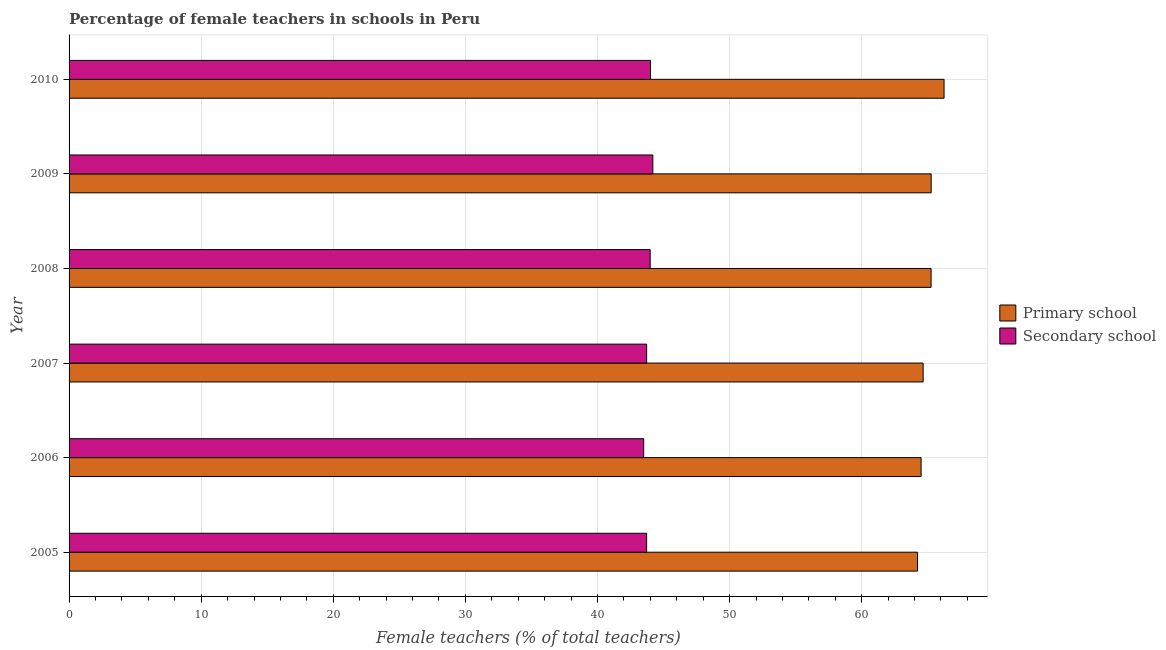How many different coloured bars are there?
Offer a terse response. 2. How many groups of bars are there?
Your response must be concise. 6. Are the number of bars on each tick of the Y-axis equal?
Ensure brevity in your answer.  Yes. What is the percentage of female teachers in secondary schools in 2010?
Give a very brief answer. 44.01. Across all years, what is the maximum percentage of female teachers in primary schools?
Provide a short and direct response. 66.23. Across all years, what is the minimum percentage of female teachers in secondary schools?
Make the answer very short. 43.5. What is the total percentage of female teachers in primary schools in the graph?
Provide a succinct answer. 390.12. What is the difference between the percentage of female teachers in secondary schools in 2007 and that in 2010?
Your answer should be compact. -0.29. What is the difference between the percentage of female teachers in secondary schools in 2005 and the percentage of female teachers in primary schools in 2007?
Provide a succinct answer. -20.93. What is the average percentage of female teachers in primary schools per year?
Provide a succinct answer. 65.02. In the year 2008, what is the difference between the percentage of female teachers in secondary schools and percentage of female teachers in primary schools?
Keep it short and to the point. -21.26. In how many years, is the percentage of female teachers in primary schools greater than 44 %?
Offer a very short reply. 6. What is the difference between the highest and the second highest percentage of female teachers in primary schools?
Provide a succinct answer. 0.97. What is the difference between the highest and the lowest percentage of female teachers in secondary schools?
Provide a succinct answer. 0.69. In how many years, is the percentage of female teachers in secondary schools greater than the average percentage of female teachers in secondary schools taken over all years?
Make the answer very short. 3. Is the sum of the percentage of female teachers in secondary schools in 2007 and 2010 greater than the maximum percentage of female teachers in primary schools across all years?
Your response must be concise. Yes. What does the 2nd bar from the top in 2008 represents?
Offer a terse response. Primary school. What does the 1st bar from the bottom in 2008 represents?
Give a very brief answer. Primary school. How many bars are there?
Make the answer very short. 12. Are the values on the major ticks of X-axis written in scientific E-notation?
Keep it short and to the point. No. Does the graph contain grids?
Give a very brief answer. Yes. Where does the legend appear in the graph?
Ensure brevity in your answer.  Center right. How many legend labels are there?
Your response must be concise. 2. What is the title of the graph?
Offer a terse response. Percentage of female teachers in schools in Peru. What is the label or title of the X-axis?
Ensure brevity in your answer.  Female teachers (% of total teachers). What is the Female teachers (% of total teachers) of Primary school in 2005?
Give a very brief answer. 64.23. What is the Female teachers (% of total teachers) of Secondary school in 2005?
Keep it short and to the point. 43.72. What is the Female teachers (% of total teachers) in Primary school in 2006?
Provide a succinct answer. 64.5. What is the Female teachers (% of total teachers) in Secondary school in 2006?
Your answer should be very brief. 43.5. What is the Female teachers (% of total teachers) in Primary school in 2007?
Give a very brief answer. 64.65. What is the Female teachers (% of total teachers) in Secondary school in 2007?
Offer a very short reply. 43.72. What is the Female teachers (% of total teachers) of Primary school in 2008?
Keep it short and to the point. 65.25. What is the Female teachers (% of total teachers) of Secondary school in 2008?
Make the answer very short. 43.99. What is the Female teachers (% of total teachers) of Primary school in 2009?
Give a very brief answer. 65.26. What is the Female teachers (% of total teachers) of Secondary school in 2009?
Keep it short and to the point. 44.19. What is the Female teachers (% of total teachers) in Primary school in 2010?
Offer a very short reply. 66.23. What is the Female teachers (% of total teachers) of Secondary school in 2010?
Offer a terse response. 44.01. Across all years, what is the maximum Female teachers (% of total teachers) of Primary school?
Ensure brevity in your answer.  66.23. Across all years, what is the maximum Female teachers (% of total teachers) of Secondary school?
Make the answer very short. 44.19. Across all years, what is the minimum Female teachers (% of total teachers) in Primary school?
Offer a terse response. 64.23. Across all years, what is the minimum Female teachers (% of total teachers) of Secondary school?
Provide a succinct answer. 43.5. What is the total Female teachers (% of total teachers) of Primary school in the graph?
Offer a very short reply. 390.12. What is the total Female teachers (% of total teachers) in Secondary school in the graph?
Provide a short and direct response. 263.13. What is the difference between the Female teachers (% of total teachers) in Primary school in 2005 and that in 2006?
Make the answer very short. -0.27. What is the difference between the Female teachers (% of total teachers) in Secondary school in 2005 and that in 2006?
Your answer should be very brief. 0.22. What is the difference between the Female teachers (% of total teachers) of Primary school in 2005 and that in 2007?
Your response must be concise. -0.42. What is the difference between the Female teachers (% of total teachers) of Secondary school in 2005 and that in 2007?
Make the answer very short. -0. What is the difference between the Female teachers (% of total teachers) in Primary school in 2005 and that in 2008?
Make the answer very short. -1.03. What is the difference between the Female teachers (% of total teachers) in Secondary school in 2005 and that in 2008?
Ensure brevity in your answer.  -0.27. What is the difference between the Female teachers (% of total teachers) of Primary school in 2005 and that in 2009?
Make the answer very short. -1.03. What is the difference between the Female teachers (% of total teachers) in Secondary school in 2005 and that in 2009?
Give a very brief answer. -0.47. What is the difference between the Female teachers (% of total teachers) in Primary school in 2005 and that in 2010?
Provide a short and direct response. -2.01. What is the difference between the Female teachers (% of total teachers) of Secondary school in 2005 and that in 2010?
Give a very brief answer. -0.29. What is the difference between the Female teachers (% of total teachers) of Primary school in 2006 and that in 2007?
Give a very brief answer. -0.15. What is the difference between the Female teachers (% of total teachers) in Secondary school in 2006 and that in 2007?
Give a very brief answer. -0.22. What is the difference between the Female teachers (% of total teachers) in Primary school in 2006 and that in 2008?
Offer a terse response. -0.76. What is the difference between the Female teachers (% of total teachers) of Secondary school in 2006 and that in 2008?
Make the answer very short. -0.49. What is the difference between the Female teachers (% of total teachers) in Primary school in 2006 and that in 2009?
Give a very brief answer. -0.76. What is the difference between the Female teachers (% of total teachers) of Secondary school in 2006 and that in 2009?
Your response must be concise. -0.69. What is the difference between the Female teachers (% of total teachers) of Primary school in 2006 and that in 2010?
Your answer should be very brief. -1.74. What is the difference between the Female teachers (% of total teachers) in Secondary school in 2006 and that in 2010?
Provide a short and direct response. -0.52. What is the difference between the Female teachers (% of total teachers) in Primary school in 2007 and that in 2008?
Your response must be concise. -0.6. What is the difference between the Female teachers (% of total teachers) of Secondary school in 2007 and that in 2008?
Offer a very short reply. -0.27. What is the difference between the Female teachers (% of total teachers) of Primary school in 2007 and that in 2009?
Provide a short and direct response. -0.61. What is the difference between the Female teachers (% of total teachers) in Secondary school in 2007 and that in 2009?
Give a very brief answer. -0.47. What is the difference between the Female teachers (% of total teachers) of Primary school in 2007 and that in 2010?
Provide a succinct answer. -1.58. What is the difference between the Female teachers (% of total teachers) of Secondary school in 2007 and that in 2010?
Your response must be concise. -0.29. What is the difference between the Female teachers (% of total teachers) in Primary school in 2008 and that in 2009?
Your answer should be very brief. -0.01. What is the difference between the Female teachers (% of total teachers) of Secondary school in 2008 and that in 2009?
Your answer should be very brief. -0.2. What is the difference between the Female teachers (% of total teachers) in Primary school in 2008 and that in 2010?
Give a very brief answer. -0.98. What is the difference between the Female teachers (% of total teachers) of Secondary school in 2008 and that in 2010?
Make the answer very short. -0.03. What is the difference between the Female teachers (% of total teachers) of Primary school in 2009 and that in 2010?
Keep it short and to the point. -0.98. What is the difference between the Female teachers (% of total teachers) of Secondary school in 2009 and that in 2010?
Your response must be concise. 0.18. What is the difference between the Female teachers (% of total teachers) of Primary school in 2005 and the Female teachers (% of total teachers) of Secondary school in 2006?
Your answer should be compact. 20.73. What is the difference between the Female teachers (% of total teachers) of Primary school in 2005 and the Female teachers (% of total teachers) of Secondary school in 2007?
Keep it short and to the point. 20.51. What is the difference between the Female teachers (% of total teachers) in Primary school in 2005 and the Female teachers (% of total teachers) in Secondary school in 2008?
Provide a short and direct response. 20.24. What is the difference between the Female teachers (% of total teachers) of Primary school in 2005 and the Female teachers (% of total teachers) of Secondary school in 2009?
Ensure brevity in your answer.  20.04. What is the difference between the Female teachers (% of total teachers) of Primary school in 2005 and the Female teachers (% of total teachers) of Secondary school in 2010?
Your answer should be very brief. 20.21. What is the difference between the Female teachers (% of total teachers) in Primary school in 2006 and the Female teachers (% of total teachers) in Secondary school in 2007?
Ensure brevity in your answer.  20.78. What is the difference between the Female teachers (% of total teachers) of Primary school in 2006 and the Female teachers (% of total teachers) of Secondary school in 2008?
Ensure brevity in your answer.  20.51. What is the difference between the Female teachers (% of total teachers) in Primary school in 2006 and the Female teachers (% of total teachers) in Secondary school in 2009?
Give a very brief answer. 20.31. What is the difference between the Female teachers (% of total teachers) of Primary school in 2006 and the Female teachers (% of total teachers) of Secondary school in 2010?
Provide a succinct answer. 20.48. What is the difference between the Female teachers (% of total teachers) in Primary school in 2007 and the Female teachers (% of total teachers) in Secondary school in 2008?
Provide a short and direct response. 20.66. What is the difference between the Female teachers (% of total teachers) in Primary school in 2007 and the Female teachers (% of total teachers) in Secondary school in 2009?
Provide a short and direct response. 20.46. What is the difference between the Female teachers (% of total teachers) of Primary school in 2007 and the Female teachers (% of total teachers) of Secondary school in 2010?
Offer a very short reply. 20.64. What is the difference between the Female teachers (% of total teachers) in Primary school in 2008 and the Female teachers (% of total teachers) in Secondary school in 2009?
Your answer should be very brief. 21.06. What is the difference between the Female teachers (% of total teachers) of Primary school in 2008 and the Female teachers (% of total teachers) of Secondary school in 2010?
Your response must be concise. 21.24. What is the difference between the Female teachers (% of total teachers) in Primary school in 2009 and the Female teachers (% of total teachers) in Secondary school in 2010?
Offer a very short reply. 21.25. What is the average Female teachers (% of total teachers) of Primary school per year?
Your response must be concise. 65.02. What is the average Female teachers (% of total teachers) of Secondary school per year?
Make the answer very short. 43.85. In the year 2005, what is the difference between the Female teachers (% of total teachers) of Primary school and Female teachers (% of total teachers) of Secondary school?
Ensure brevity in your answer.  20.51. In the year 2006, what is the difference between the Female teachers (% of total teachers) of Primary school and Female teachers (% of total teachers) of Secondary school?
Provide a short and direct response. 21. In the year 2007, what is the difference between the Female teachers (% of total teachers) in Primary school and Female teachers (% of total teachers) in Secondary school?
Keep it short and to the point. 20.93. In the year 2008, what is the difference between the Female teachers (% of total teachers) in Primary school and Female teachers (% of total teachers) in Secondary school?
Offer a terse response. 21.26. In the year 2009, what is the difference between the Female teachers (% of total teachers) of Primary school and Female teachers (% of total teachers) of Secondary school?
Offer a very short reply. 21.07. In the year 2010, what is the difference between the Female teachers (% of total teachers) of Primary school and Female teachers (% of total teachers) of Secondary school?
Give a very brief answer. 22.22. What is the ratio of the Female teachers (% of total teachers) in Primary school in 2005 to that in 2006?
Your answer should be very brief. 1. What is the ratio of the Female teachers (% of total teachers) of Secondary school in 2005 to that in 2006?
Ensure brevity in your answer.  1.01. What is the ratio of the Female teachers (% of total teachers) of Primary school in 2005 to that in 2007?
Your answer should be compact. 0.99. What is the ratio of the Female teachers (% of total teachers) of Primary school in 2005 to that in 2008?
Your answer should be very brief. 0.98. What is the ratio of the Female teachers (% of total teachers) of Primary school in 2005 to that in 2009?
Offer a very short reply. 0.98. What is the ratio of the Female teachers (% of total teachers) in Secondary school in 2005 to that in 2009?
Offer a very short reply. 0.99. What is the ratio of the Female teachers (% of total teachers) in Primary school in 2005 to that in 2010?
Ensure brevity in your answer.  0.97. What is the ratio of the Female teachers (% of total teachers) of Secondary school in 2005 to that in 2010?
Your answer should be very brief. 0.99. What is the ratio of the Female teachers (% of total teachers) of Secondary school in 2006 to that in 2007?
Provide a short and direct response. 0.99. What is the ratio of the Female teachers (% of total teachers) in Primary school in 2006 to that in 2008?
Provide a succinct answer. 0.99. What is the ratio of the Female teachers (% of total teachers) of Primary school in 2006 to that in 2009?
Offer a very short reply. 0.99. What is the ratio of the Female teachers (% of total teachers) of Secondary school in 2006 to that in 2009?
Provide a short and direct response. 0.98. What is the ratio of the Female teachers (% of total teachers) in Primary school in 2006 to that in 2010?
Ensure brevity in your answer.  0.97. What is the ratio of the Female teachers (% of total teachers) in Secondary school in 2006 to that in 2010?
Make the answer very short. 0.99. What is the ratio of the Female teachers (% of total teachers) in Secondary school in 2007 to that in 2008?
Provide a short and direct response. 0.99. What is the ratio of the Female teachers (% of total teachers) of Primary school in 2007 to that in 2009?
Make the answer very short. 0.99. What is the ratio of the Female teachers (% of total teachers) of Secondary school in 2007 to that in 2009?
Your answer should be very brief. 0.99. What is the ratio of the Female teachers (% of total teachers) in Primary school in 2007 to that in 2010?
Your answer should be compact. 0.98. What is the ratio of the Female teachers (% of total teachers) of Secondary school in 2007 to that in 2010?
Provide a succinct answer. 0.99. What is the ratio of the Female teachers (% of total teachers) in Primary school in 2008 to that in 2009?
Give a very brief answer. 1. What is the ratio of the Female teachers (% of total teachers) in Primary school in 2008 to that in 2010?
Your answer should be very brief. 0.99. What is the ratio of the Female teachers (% of total teachers) of Secondary school in 2009 to that in 2010?
Your answer should be compact. 1. What is the difference between the highest and the second highest Female teachers (% of total teachers) of Primary school?
Provide a short and direct response. 0.98. What is the difference between the highest and the second highest Female teachers (% of total teachers) of Secondary school?
Your response must be concise. 0.18. What is the difference between the highest and the lowest Female teachers (% of total teachers) of Primary school?
Make the answer very short. 2.01. What is the difference between the highest and the lowest Female teachers (% of total teachers) in Secondary school?
Your answer should be very brief. 0.69. 